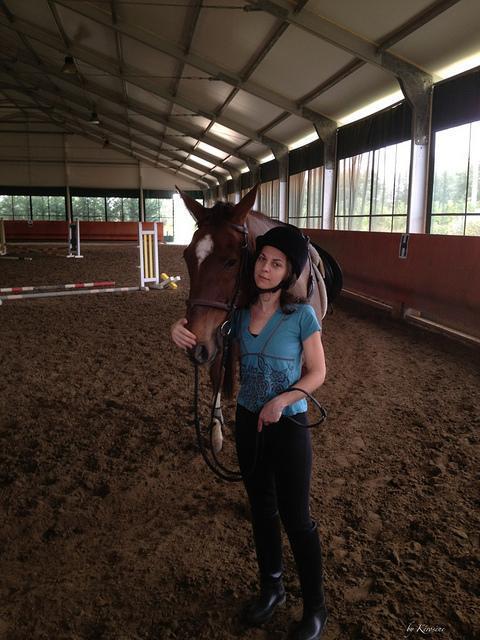How many animals are there?
Give a very brief answer. 1. How many people are blurry?
Give a very brief answer. 0. 